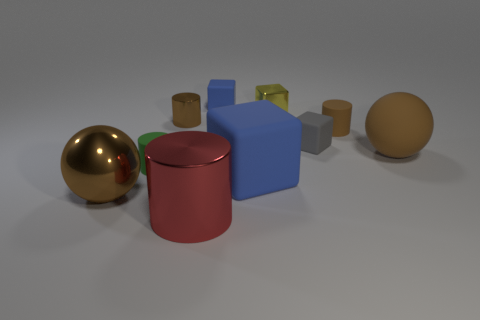Subtract all green spheres. Subtract all brown cubes. How many spheres are left? 2 Subtract all cylinders. How many objects are left? 6 Add 2 tiny purple metallic blocks. How many tiny purple metallic blocks exist? 2 Subtract 0 purple cylinders. How many objects are left? 10 Subtract all brown matte spheres. Subtract all blue things. How many objects are left? 7 Add 1 cubes. How many cubes are left? 5 